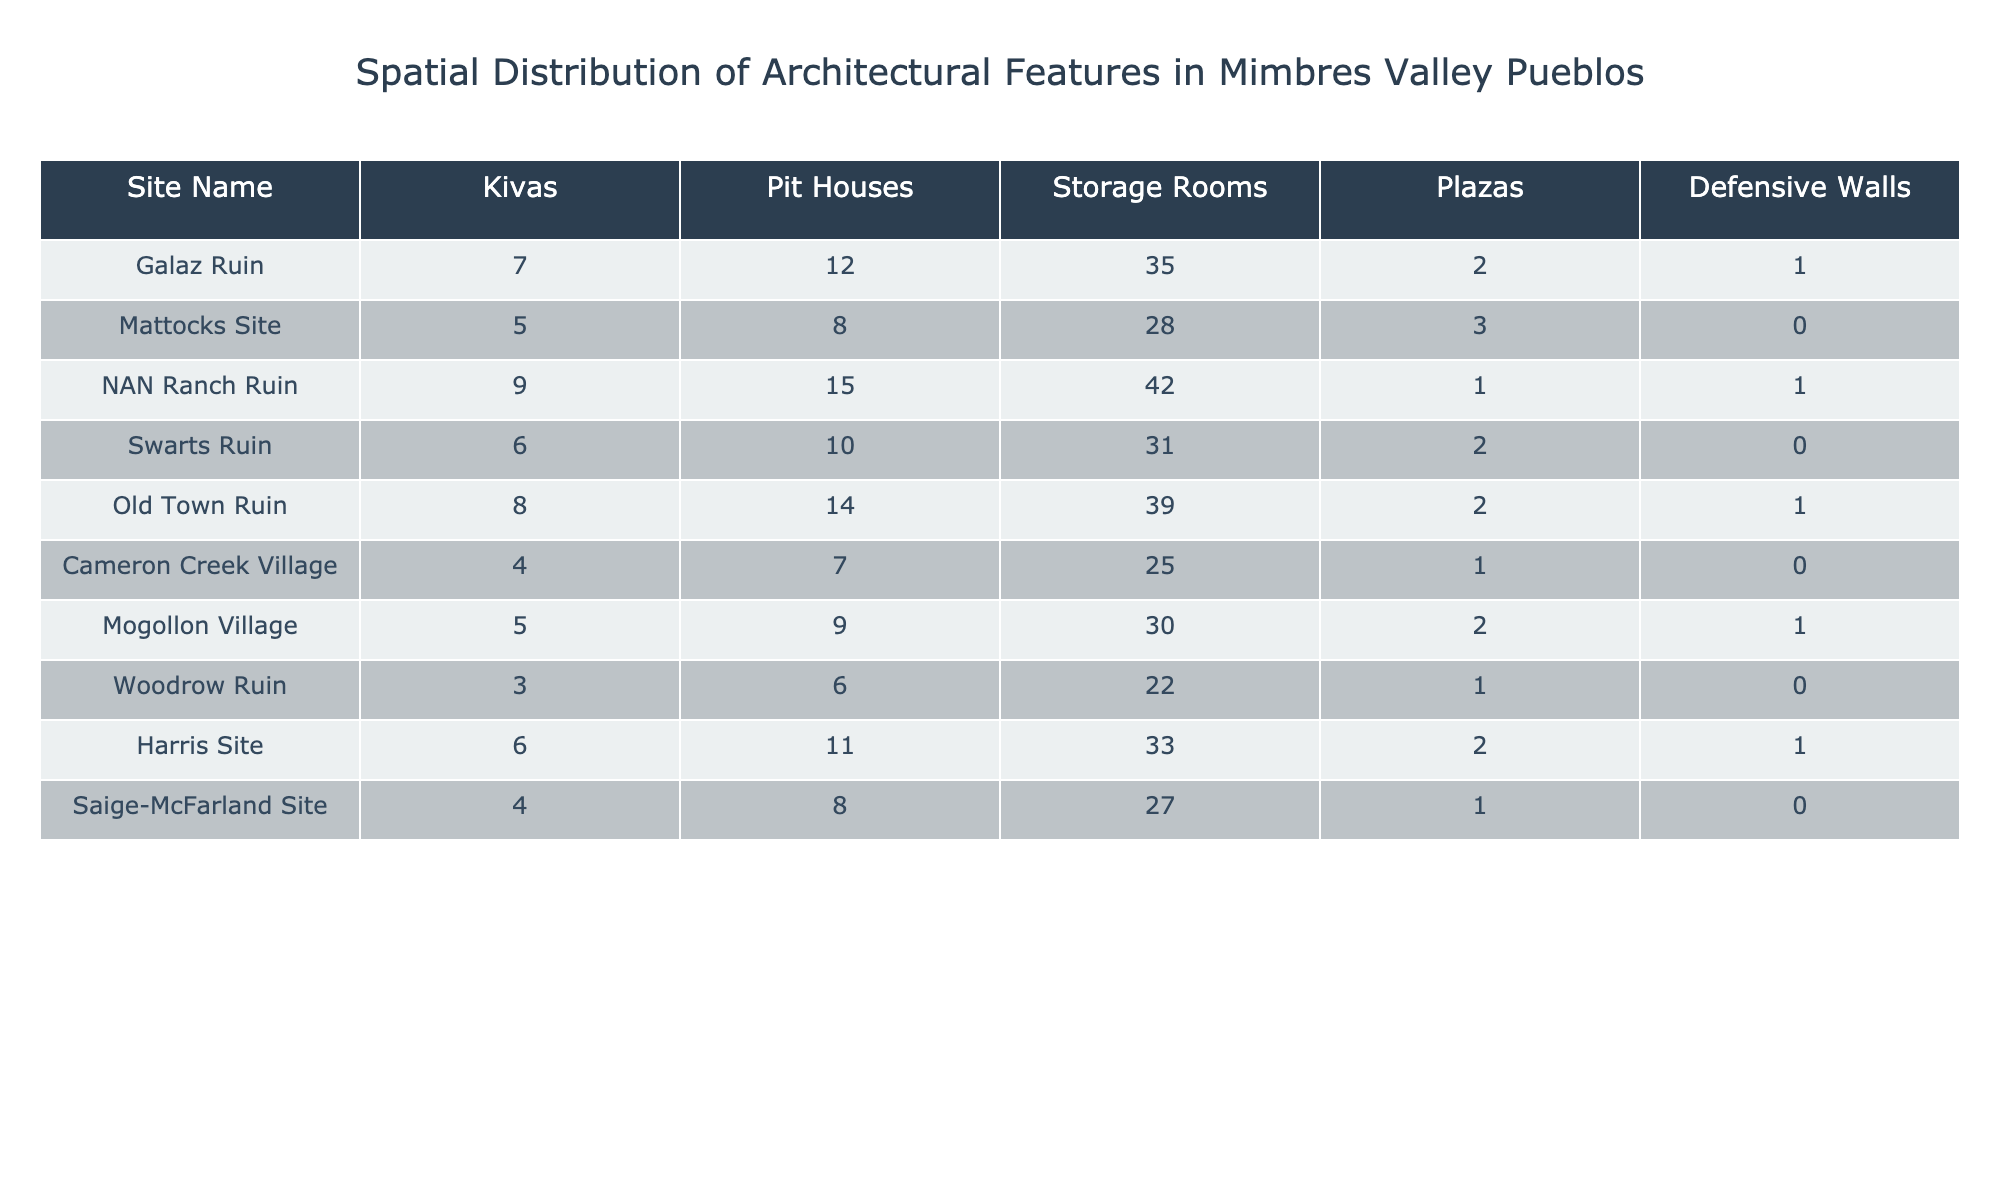What is the total number of kivas across all sites? To find the total number of kivas, I will sum the values in the Kivas column: 7 + 5 + 9 + 6 + 8 + 4 + 5 + 3 + 6 + 4 = 57.
Answer: 57 Which site has the highest number of storage rooms? By examining the Storage Rooms column, I see that NAN Ranch Ruin has the highest number with 42 rooms.
Answer: NAN Ranch Ruin How many pit houses are found in the Mogollon Village? From the table, the number of pit houses in Mogollon Village is directly provided as 9.
Answer: 9 Is there a site with more than 30 plazas? Looking at the Plazas column, none of the values exceed 3, so the answer is no.
Answer: No What is the average number of defensive walls across all sites? The total number of defensive walls is 1 + 0 + 1 + 0 + 1 + 0 + 1 + 0 + 1 + 0 = 5 and there are 10 sites, so the average is 5/10 = 0.5.
Answer: 0.5 What's the difference in the number of storage rooms between the site with the most and the site with the least? The site with the most storage rooms is NAN Ranch Ruin with 42, and the site with the least is Woodrow Ruin with 22. The difference is 42 - 22 = 20.
Answer: 20 How many sites have defensive walls? I will count the number of sites where the value in the Defensive Walls column is greater than 0: Galaz Ruin, NAN Ranch Ruin, Old Town Ruin, Harris Site all have defensive walls. This gives a total of 4 sites.
Answer: 4 What is the total number of plazas in Mimbres Valley pueblos? Summing up the values from the Plazas column gives: 2 + 3 + 1 + 2 + 2 + 1 + 2 + 1 + 2 + 1 = 16.
Answer: 16 Which site has the least number of kivas? Looking through the Kivas column, Woodrow Ruin has the least with 3 kivas.
Answer: Woodrow Ruin What is the ratio of pit houses to storage rooms for the Mattocks Site? For the Mattocks Site, there are 8 pit houses and 28 storage rooms. The ratio is 8:28, which simplifies to 2:7.
Answer: 2:7 What site has the second highest number of kivas? The kivas count in descending order is: NAN Ranch Ruin (9), Old Town Ruin (8), Galaz Ruin (7), so the second highest is Old Town Ruin.
Answer: Old Town Ruin 